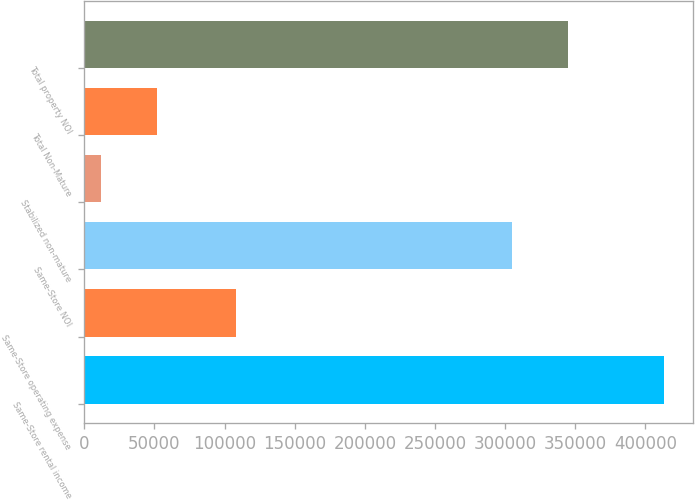Convert chart. <chart><loc_0><loc_0><loc_500><loc_500><bar_chart><fcel>Same-Store rental income<fcel>Same-Store operating expense<fcel>Same-Store NOI<fcel>Stabilized non-mature<fcel>Total Non-Mature<fcel>Total property NOI<nl><fcel>413081<fcel>108371<fcel>304710<fcel>11759<fcel>51891.2<fcel>344842<nl></chart> 